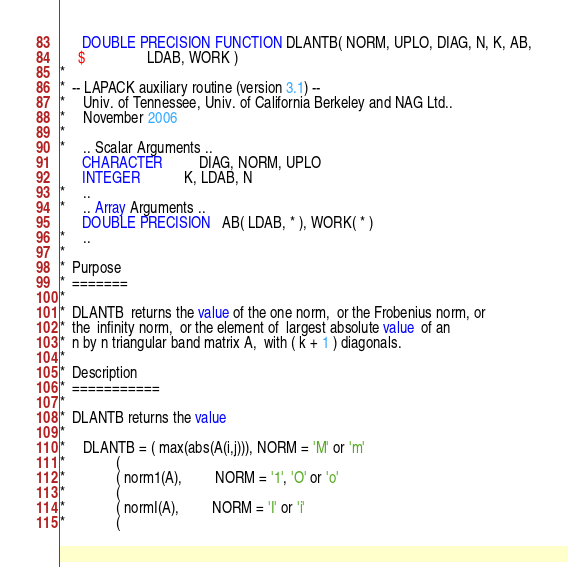<code> <loc_0><loc_0><loc_500><loc_500><_FORTRAN_>      DOUBLE PRECISION FUNCTION DLANTB( NORM, UPLO, DIAG, N, K, AB,
     $                 LDAB, WORK )
*
*  -- LAPACK auxiliary routine (version 3.1) --
*     Univ. of Tennessee, Univ. of California Berkeley and NAG Ltd..
*     November 2006
*
*     .. Scalar Arguments ..
      CHARACTER          DIAG, NORM, UPLO
      INTEGER            K, LDAB, N
*     ..
*     .. Array Arguments ..
      DOUBLE PRECISION   AB( LDAB, * ), WORK( * )
*     ..
*
*  Purpose
*  =======
*
*  DLANTB  returns the value of the one norm,  or the Frobenius norm, or
*  the  infinity norm,  or the element of  largest absolute value  of an
*  n by n triangular band matrix A,  with ( k + 1 ) diagonals.
*
*  Description
*  ===========
*
*  DLANTB returns the value
*
*     DLANTB = ( max(abs(A(i,j))), NORM = 'M' or 'm'
*              (
*              ( norm1(A),         NORM = '1', 'O' or 'o'
*              (
*              ( normI(A),         NORM = 'I' or 'i'
*              (</code> 